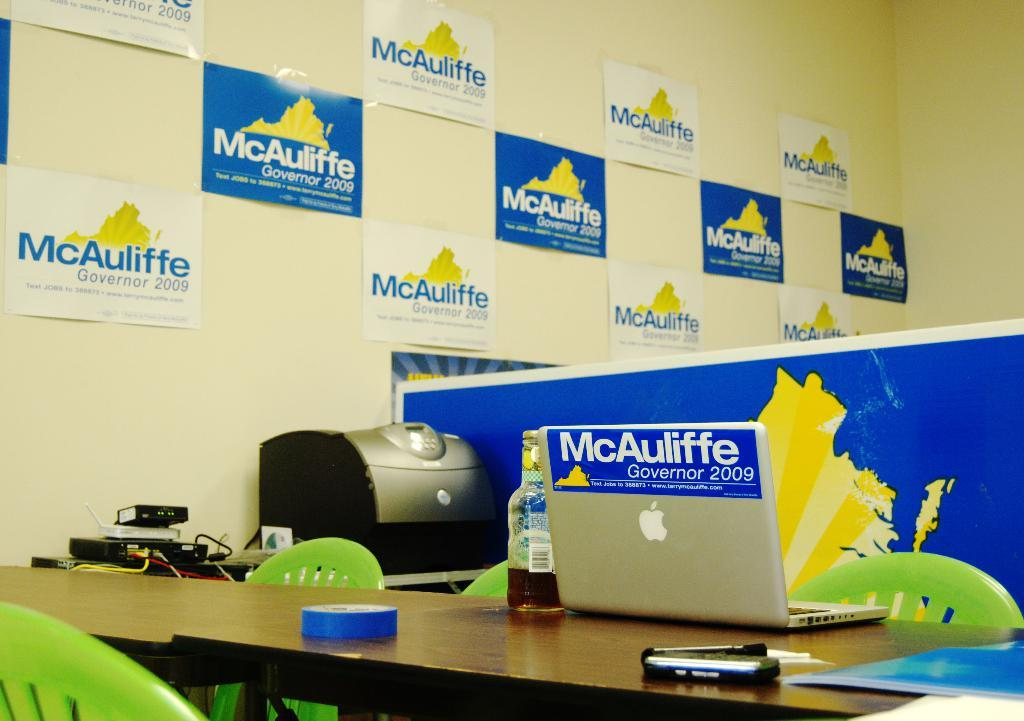<image>
Present a compact description of the photo's key features. A wall with several advertising posters for a political campaign. 